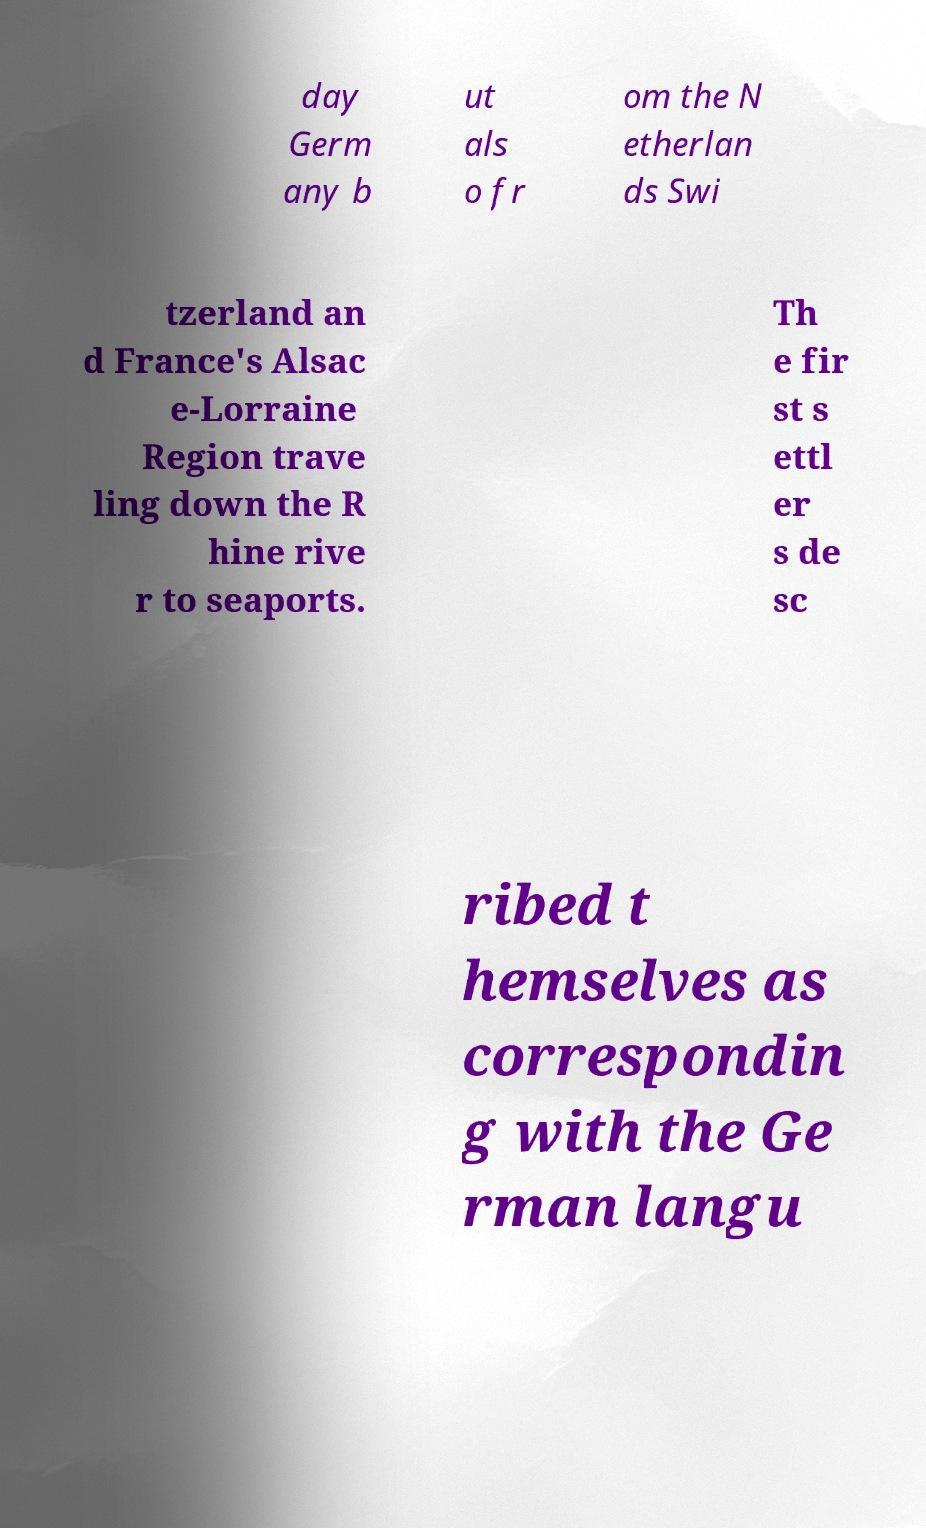I need the written content from this picture converted into text. Can you do that? day Germ any b ut als o fr om the N etherlan ds Swi tzerland an d France's Alsac e-Lorraine Region trave ling down the R hine rive r to seaports. Th e fir st s ettl er s de sc ribed t hemselves as correspondin g with the Ge rman langu 